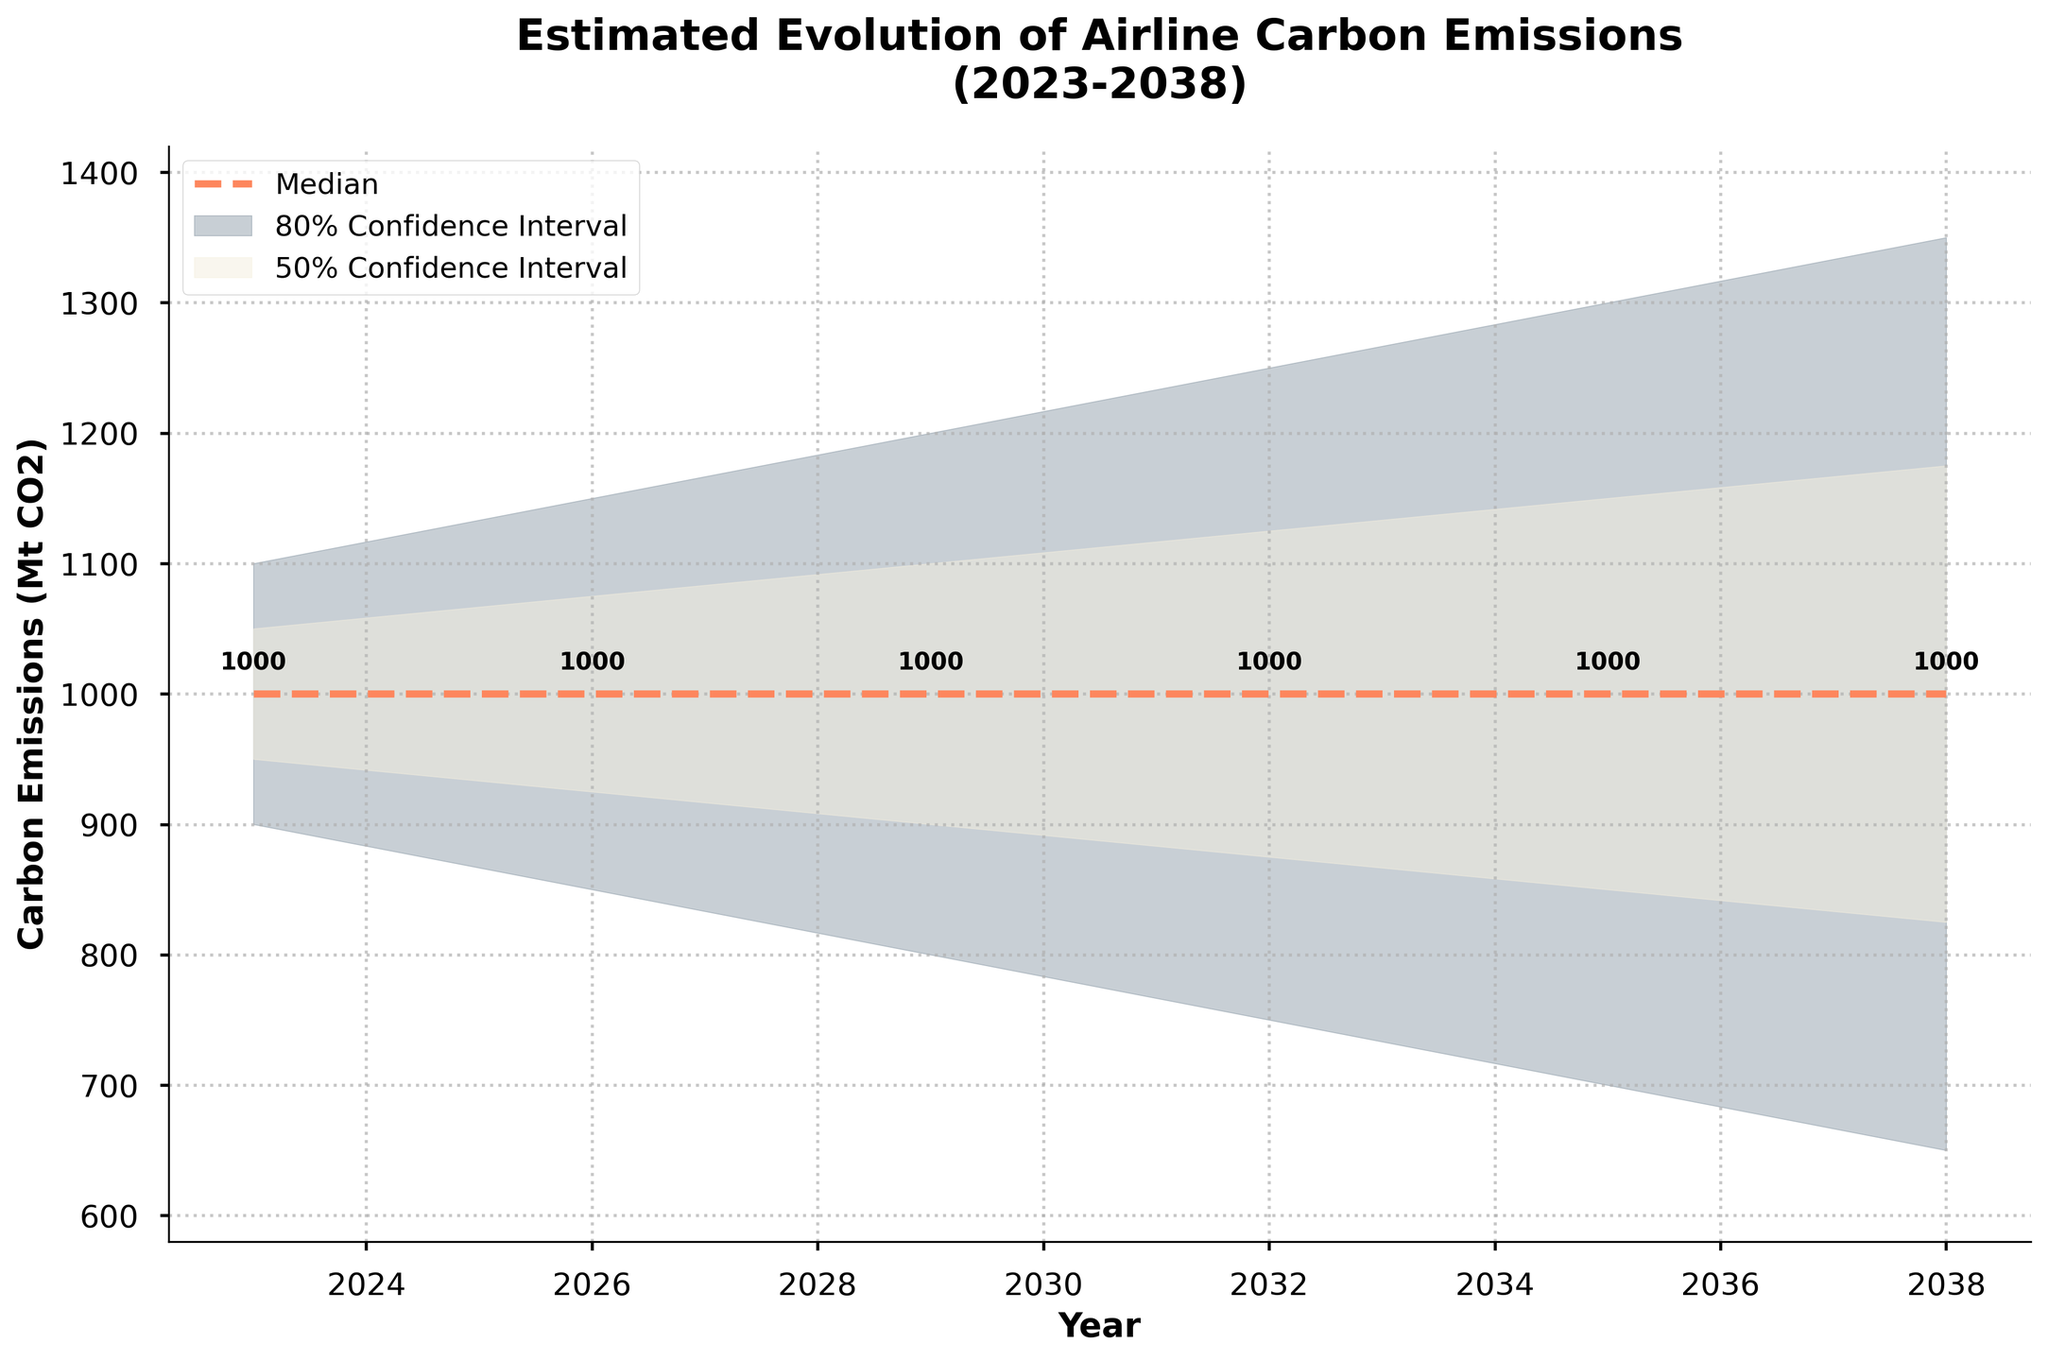What is the title of the chart? The title is usually located at the top of the chart and summarizes what the chart is about. By looking at the top center of the chart, we can identify the title.
Answer: Estimated Evolution of Airline Carbon Emissions (2023-2038) What does the y-axis represent in the chart? The y-axis label provides information on what is being measured vertically. By looking at the left-hand side of the chart, we can find this label.
Answer: Carbon Emissions (Mt CO2) What is the median estimate for carbon emissions in 2032? The median values are shown as a dashed line in the chart. By following the line corresponding to 2032, the annotated value near this line gives the median estimate.
Answer: 1000 Mt CO2 How does the lower bound for carbon emissions change from 2023 to 2038? To find the change in the lower bound, we need to look at the lower bound values for 2023 and 2038 on the chart and calculate the difference. The values are annotated on the filled areas.
Answer: Decreases from 900 to 650 Mt CO2 What is the range of carbon emissions (lower to upper bound) in 2029? The lower and upper bounds for 2029 are given in the chart. By subtracting the lower bound value from the upper bound value for that year, we can find the range.
Answer: 400 Mt CO2 Between which years does the median carbon emissions remain constant? Observing the median line (dashed line) on the chart, we can see where it stays at the same level by reading the annotated values.
Answer: 2029 to 2038 By how much does the median carbon emissions estimate decrease from 2023 to 2035? We look at the median values for 2023 and 2035 from the chart, then compute the difference.
Answer: 0 Mt CO2 Which year shows the narrowest range for the 80% confidence interval? The 80% confidence interval is represented by the area filled with lighter color. By comparing the widths of this area across years in the chart, we determine the year with the narrowest interval.
Answer: 2023 By what percentage does the upper bound of carbon emissions decrease between 2023 and 2026? To find the percentage decrease, subtract the upper bound value for 2026 from the upper bound value for 2023, divide the result by the 2023 value, and multiply by 100. This calculation compares the values shown on the chart.
Answer: 4.5% What is the expected trend for the upper mid-confidence interval from 2023 to 2038? Observing the area filled with the medium color, follow the upper mid-confidence interval values over the years from start to the end. The trend indicates whether the values overall increase, decrease, or remain constant.
Answer: Decrease 